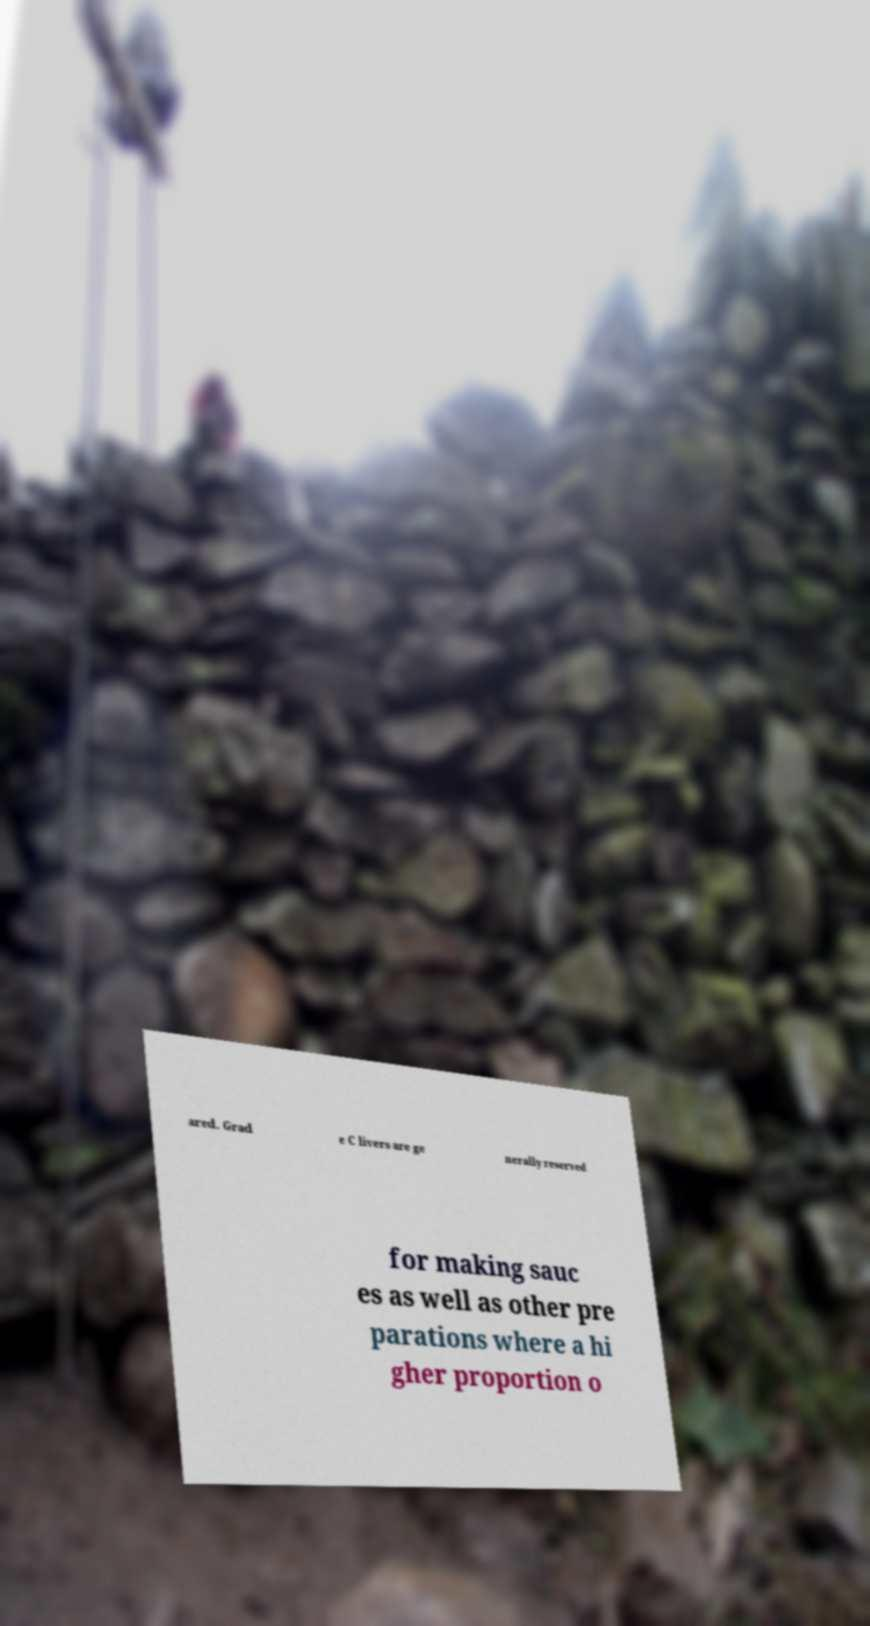What messages or text are displayed in this image? I need them in a readable, typed format. ared. Grad e C livers are ge nerally reserved for making sauc es as well as other pre parations where a hi gher proportion o 